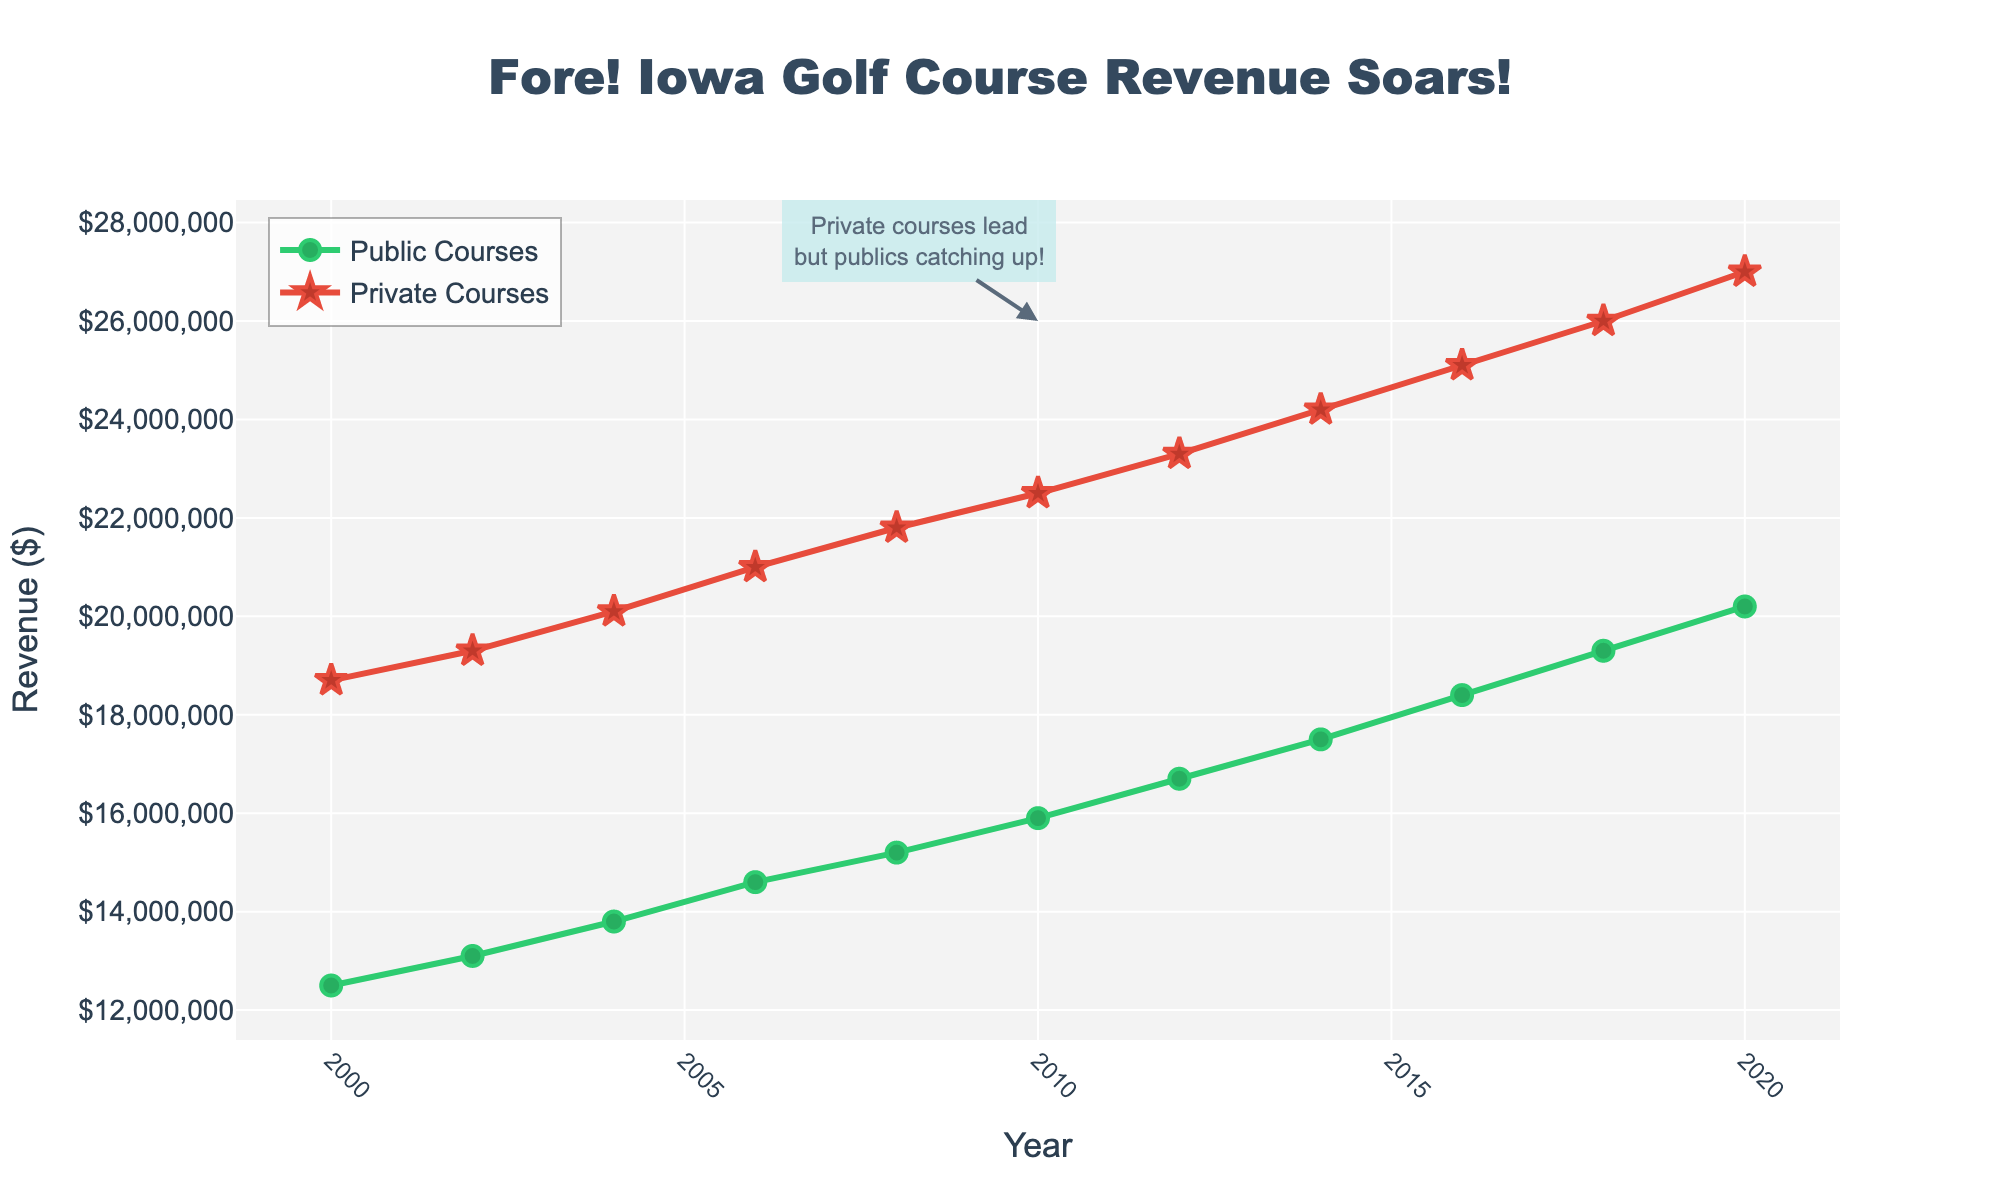Which year saw the highest revenue for both public and private courses combined? To find the highest combined revenue, add the revenues for each year and compare. For 2020, the combined revenue is 20,200,000 + 27,000,000 = 47,200,000, which is the highest.
Answer: 2020 Which course type had a faster rate of revenue increase from 2000 to 2020? Calculate the difference in revenue for each course type from 2000 to 2020, then compare the differences. Public: 20,200,000 - 12,500,000 = 7,700,000. Private: 27,000,000 - 18,700,000 = 8,300,000. Although private courses had a higher difference, the rate (percentage increase) needs consideration. Public courses increased by 7,700,000/12,500,000 ≈ 0.616 (61.6%) while private courses increased by 8,300,000/18,700,000 ≈ 0.444 (44.4%).
Answer: Public How much more revenue did private courses generate compared to public courses in 2008? Subtract the public revenue from the private revenue in 2008. 21,800,000 - 15,200,000 = 6,600,000. Thus, private courses generated 6.6 million more.
Answer: 6,600,000 What is the average revenue for public courses from 2000 to 2020? Add all the revenues for public courses and divide by the number of data points. (12,500,000 + 13,100,000 + 13,800,000 + 14,600,000 + 15,200,000 + 15,900,000 + 16,700,000 + 17,500,000 + 18,400,000 + 19,300,000 + 20,200,000) / 11 = 16,227,272.73.
Answer: 16,227,272.73 Which course type had more consistent growth in revenue based on the visual slope of the lines? Comparing the slopes of the lines visually, public courses show a more consistent linear growth, while private courses show slight variations.
Answer: Public What annotation is added in the figure and what does it highlight? There's an annotation at the 2010 data point, highlighting that private courses lead but public courses are catching up, signifying a narrowing revenue gap.
Answer: Private courses lead but publics catching up In which year did public courses first exceed $15,000,000 in revenue? By examining the vertical position of the green line, public courses first exceeded $15,000,000 between 2004 and 2006.
Answer: 2006 From the visual, how is the data for public and private courses represented? Public courses are represented by green lines and circle markers, while private courses are visualized by red lines and star markers.
Answer: Green and circle for public, red and star for private What is the total revenue generated by public courses from 2000 to 2020? Calculate the sum of annual revenues for public courses from 2000 to 2020: 12,500,000 + 13,100,000 + 13,800,000 + 14,600,000 + 15,200,000 + 15,900,000 + 16,700,000 + 17,500,000 + 18,400,000 + 19,300,000 + 20,200,000 = 176,200,000.
Answer: 176,200,000 